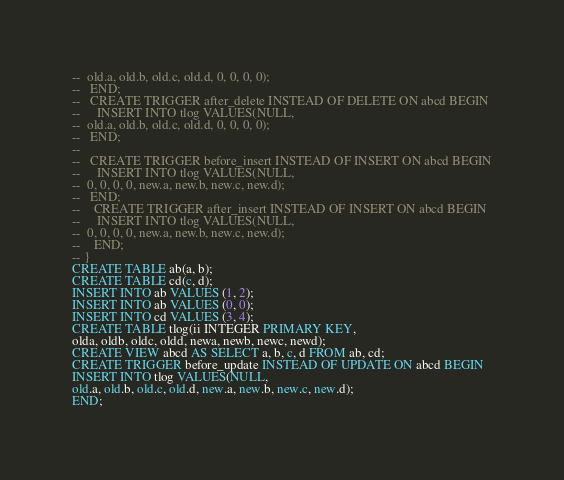Convert code to text. <code><loc_0><loc_0><loc_500><loc_500><_SQL_>-- 	old.a, old.b, old.c, old.d, 0, 0, 0, 0);
--   END;
--   CREATE TRIGGER after_delete INSTEAD OF DELETE ON abcd BEGIN
--     INSERT INTO tlog VALUES(NULL, 
-- 	old.a, old.b, old.c, old.d, 0, 0, 0, 0);
--   END;
-- 
--   CREATE TRIGGER before_insert INSTEAD OF INSERT ON abcd BEGIN
--     INSERT INTO tlog VALUES(NULL, 
-- 	0, 0, 0, 0, new.a, new.b, new.c, new.d);
--   END;
--    CREATE TRIGGER after_insert INSTEAD OF INSERT ON abcd BEGIN
--     INSERT INTO tlog VALUES(NULL, 
-- 	0, 0, 0, 0, new.a, new.b, new.c, new.d);
--    END;
-- }
CREATE TABLE ab(a, b);
CREATE TABLE cd(c, d);
INSERT INTO ab VALUES (1, 2);
INSERT INTO ab VALUES (0, 0);
INSERT INTO cd VALUES (3, 4);
CREATE TABLE tlog(ii INTEGER PRIMARY KEY, 
olda, oldb, oldc, oldd, newa, newb, newc, newd);
CREATE VIEW abcd AS SELECT a, b, c, d FROM ab, cd;
CREATE TRIGGER before_update INSTEAD OF UPDATE ON abcd BEGIN
INSERT INTO tlog VALUES(NULL, 
old.a, old.b, old.c, old.d, new.a, new.b, new.c, new.d);
END;</code> 